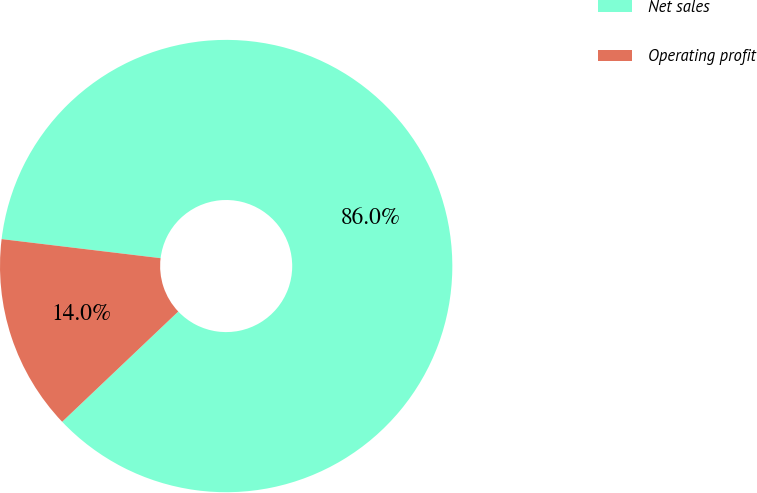Convert chart to OTSL. <chart><loc_0><loc_0><loc_500><loc_500><pie_chart><fcel>Net sales<fcel>Operating profit<nl><fcel>86.01%<fcel>13.99%<nl></chart> 